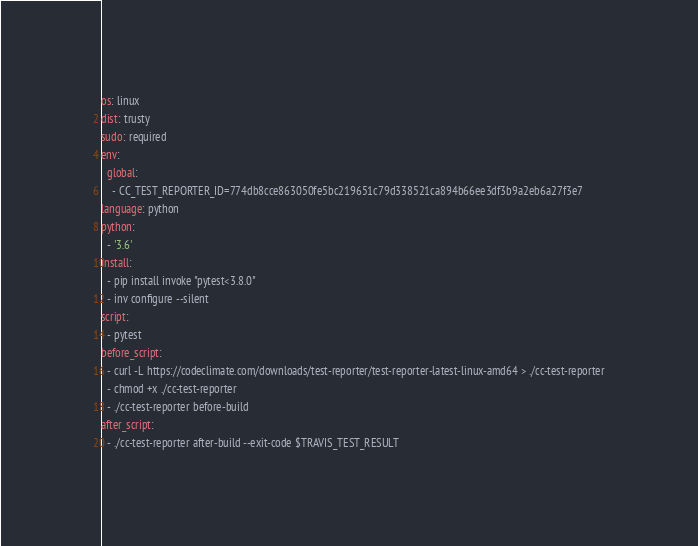<code> <loc_0><loc_0><loc_500><loc_500><_YAML_>os: linux
dist: trusty
sudo: required
env:
  global:
    - CC_TEST_REPORTER_ID=774db8cce863050fe5bc219651c79d338521ca894b66ee3df3b9a2eb6a27f3e7
language: python
python:
  - '3.6'
install:
  - pip install invoke "pytest<3.8.0"
  - inv configure --silent
script:
  - pytest
before_script:
  - curl -L https://codeclimate.com/downloads/test-reporter/test-reporter-latest-linux-amd64 > ./cc-test-reporter
  - chmod +x ./cc-test-reporter
  - ./cc-test-reporter before-build
after_script:
  - ./cc-test-reporter after-build --exit-code $TRAVIS_TEST_RESULT
</code> 